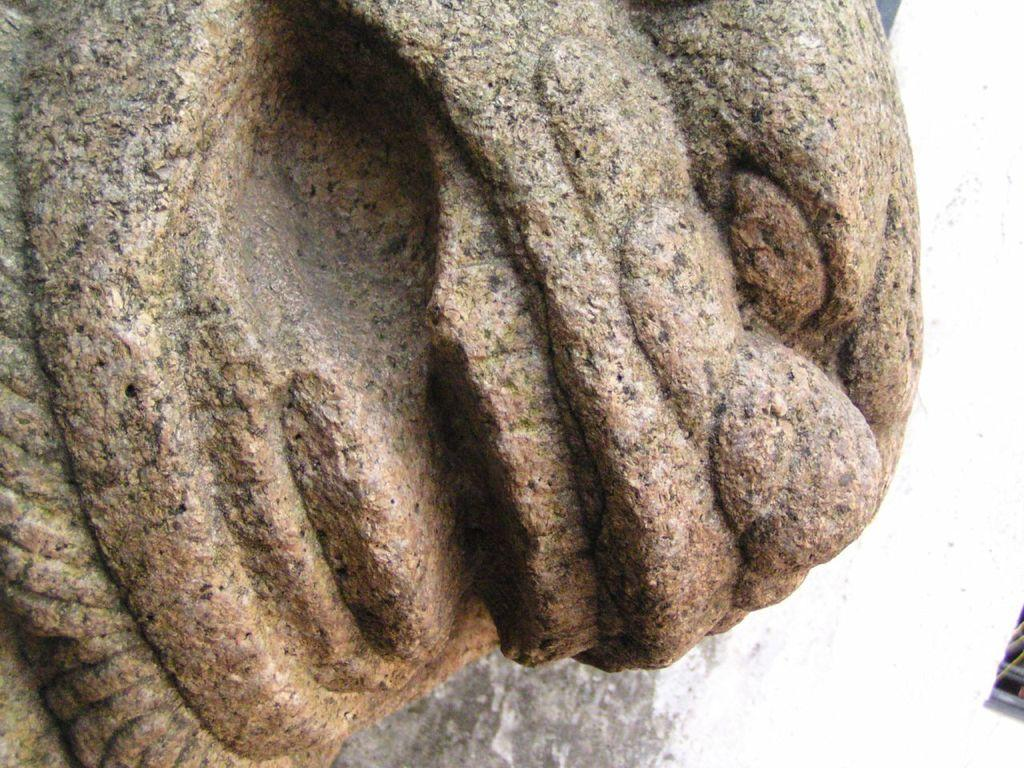What is the main subject of the image? There is a rock statue in the image. Can you describe the statue in more detail? Unfortunately, the provided facts do not offer any additional details about the statue. Is there anything else in the image besides the rock statue? The facts do not mention any other objects or subjects in the image. What is the condition of the vessel in the image? There is no vessel present in the image; it only features a rock statue. 